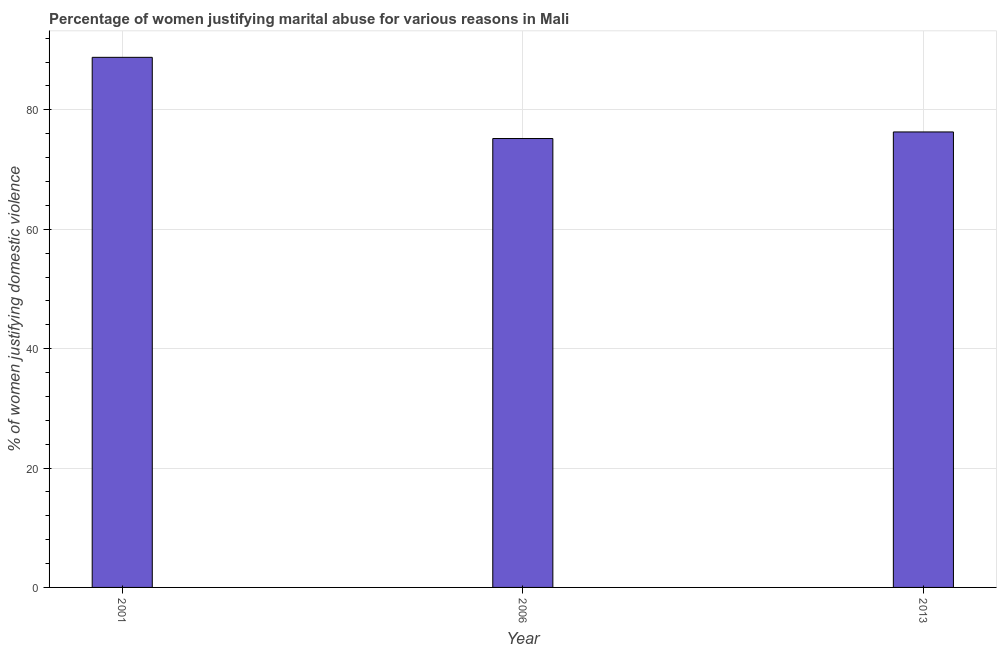What is the title of the graph?
Provide a succinct answer. Percentage of women justifying marital abuse for various reasons in Mali. What is the label or title of the X-axis?
Your answer should be very brief. Year. What is the label or title of the Y-axis?
Give a very brief answer. % of women justifying domestic violence. What is the percentage of women justifying marital abuse in 2013?
Make the answer very short. 76.3. Across all years, what is the maximum percentage of women justifying marital abuse?
Provide a short and direct response. 88.8. Across all years, what is the minimum percentage of women justifying marital abuse?
Offer a very short reply. 75.2. In which year was the percentage of women justifying marital abuse maximum?
Provide a short and direct response. 2001. What is the sum of the percentage of women justifying marital abuse?
Your answer should be compact. 240.3. What is the difference between the percentage of women justifying marital abuse in 2006 and 2013?
Provide a succinct answer. -1.1. What is the average percentage of women justifying marital abuse per year?
Ensure brevity in your answer.  80.1. What is the median percentage of women justifying marital abuse?
Give a very brief answer. 76.3. Do a majority of the years between 2001 and 2013 (inclusive) have percentage of women justifying marital abuse greater than 28 %?
Offer a very short reply. Yes. What is the ratio of the percentage of women justifying marital abuse in 2001 to that in 2013?
Make the answer very short. 1.16. Is the percentage of women justifying marital abuse in 2001 less than that in 2006?
Offer a terse response. No. Is the difference between the percentage of women justifying marital abuse in 2001 and 2013 greater than the difference between any two years?
Your answer should be compact. No. What is the difference between the highest and the second highest percentage of women justifying marital abuse?
Give a very brief answer. 12.5. How many bars are there?
Ensure brevity in your answer.  3. Are all the bars in the graph horizontal?
Ensure brevity in your answer.  No. What is the difference between two consecutive major ticks on the Y-axis?
Ensure brevity in your answer.  20. Are the values on the major ticks of Y-axis written in scientific E-notation?
Your answer should be compact. No. What is the % of women justifying domestic violence of 2001?
Your answer should be very brief. 88.8. What is the % of women justifying domestic violence of 2006?
Ensure brevity in your answer.  75.2. What is the % of women justifying domestic violence in 2013?
Make the answer very short. 76.3. What is the difference between the % of women justifying domestic violence in 2001 and 2006?
Your response must be concise. 13.6. What is the difference between the % of women justifying domestic violence in 2006 and 2013?
Offer a terse response. -1.1. What is the ratio of the % of women justifying domestic violence in 2001 to that in 2006?
Your answer should be very brief. 1.18. What is the ratio of the % of women justifying domestic violence in 2001 to that in 2013?
Your answer should be very brief. 1.16. What is the ratio of the % of women justifying domestic violence in 2006 to that in 2013?
Your answer should be very brief. 0.99. 